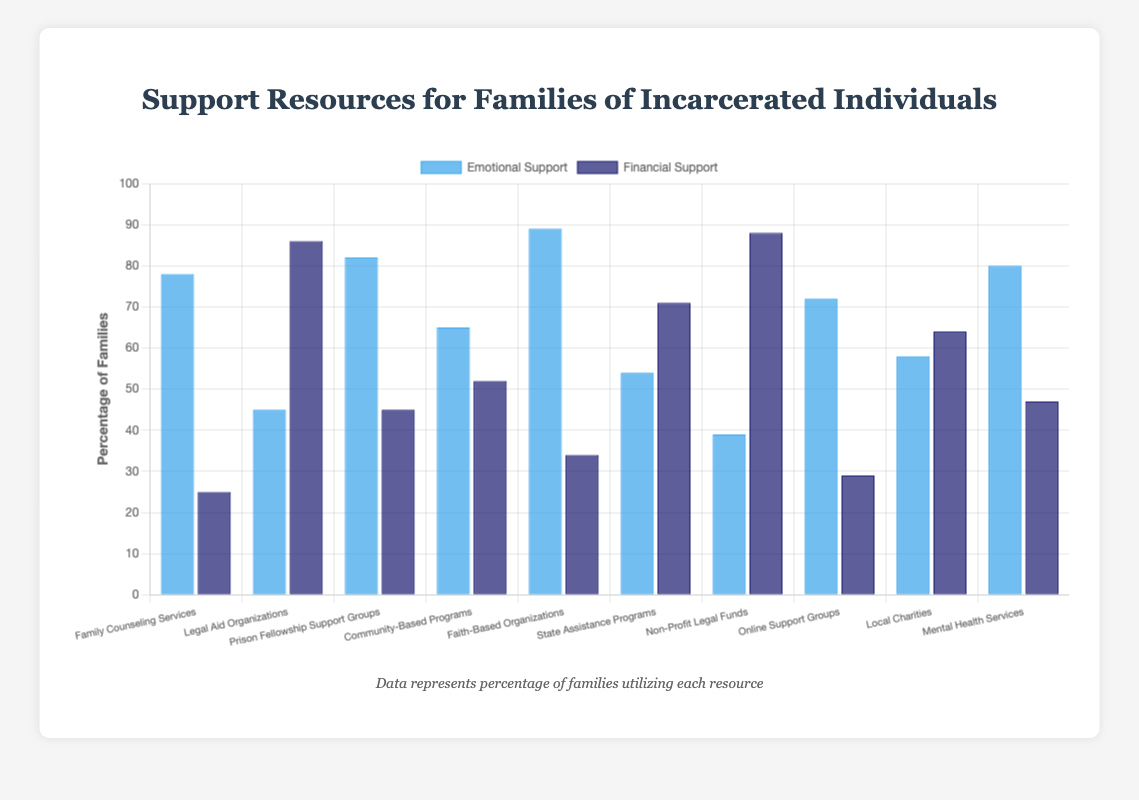Which support resource provides the highest level of emotional support? By looking at the blue bars representing emotional support, the bar for "Faith-Based Organizations" is the tallest.
Answer: Faith-Based Organizations Which resource provides the lowest level of financial support? By examining the dark blue bars representing financial support, the bar for "Family Counseling Services" is the shortest.
Answer: Family Counseling Services Is there any resource where emotional and financial support levels are almost equal? By comparing the lengths of blue and dark blue bars for each resource, "Prison Fellowship Support Groups" has similar levels of emotional (82) and financial support (45).
Answer: No What is the sum of the financial support percentages for "Legal Aid Organizations" and "Non-Profit Legal Funds"? Add the financial support percentages of "Legal Aid Organizations" (86) and "Non-Profit Legal Funds" (88): 86 + 88 = 174.
Answer: 174 How much higher is the emotional support for "Faith-Based Organizations" compared to "Non-Profit Legal Funds"? Subtract the emotional support percentage of "Non-Profit Legal Funds" (39) from "Faith-Based Organizations" (89): 89 - 39 = 50.
Answer: 50 Which resource has a higher level of financial support, "State Assistance Programs" or "Local Charities"? Compare the heights of the dark blue bars for "State Assistance Programs" (71) and "Local Charities" (64). "State Assistance Programs" is higher.
Answer: State Assistance Programs Which resource offers more overall support (sum of emotional and financial), "Mental Health Services" or "Community-Based Programs"? Calculate the sums: Mental Health Services (80 + 47 = 127), Community-Based Programs (65 + 52 = 117), and compare the sums. Mental Health Services is higher.
Answer: Mental Health Services What is the average emotional support provided by community-based and state assistance programs? Sum the emotional support percentages of these resources: Community-Based Programs (65) + State Assistance Programs (54) = 119. Divide by 2: 119/2 = 59.5.
Answer: 59.5 